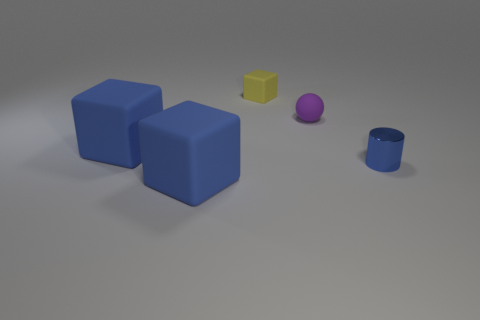Subtract all yellow cylinders. How many blue cubes are left? 2 Subtract all large blue matte blocks. How many blocks are left? 1 Add 3 large gray balls. How many objects exist? 8 Subtract all cubes. How many objects are left? 2 Subtract 0 red cubes. How many objects are left? 5 Subtract all blue metal cylinders. Subtract all small green cubes. How many objects are left? 4 Add 4 yellow cubes. How many yellow cubes are left? 5 Add 1 big yellow matte spheres. How many big yellow matte spheres exist? 1 